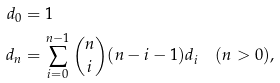Convert formula to latex. <formula><loc_0><loc_0><loc_500><loc_500>d _ { 0 } & = 1 \\ d _ { n } & = \sum _ { i = 0 } ^ { n - 1 } \binom { n } { i } ( n - i - 1 ) d _ { i } \quad ( n > 0 ) ,</formula> 